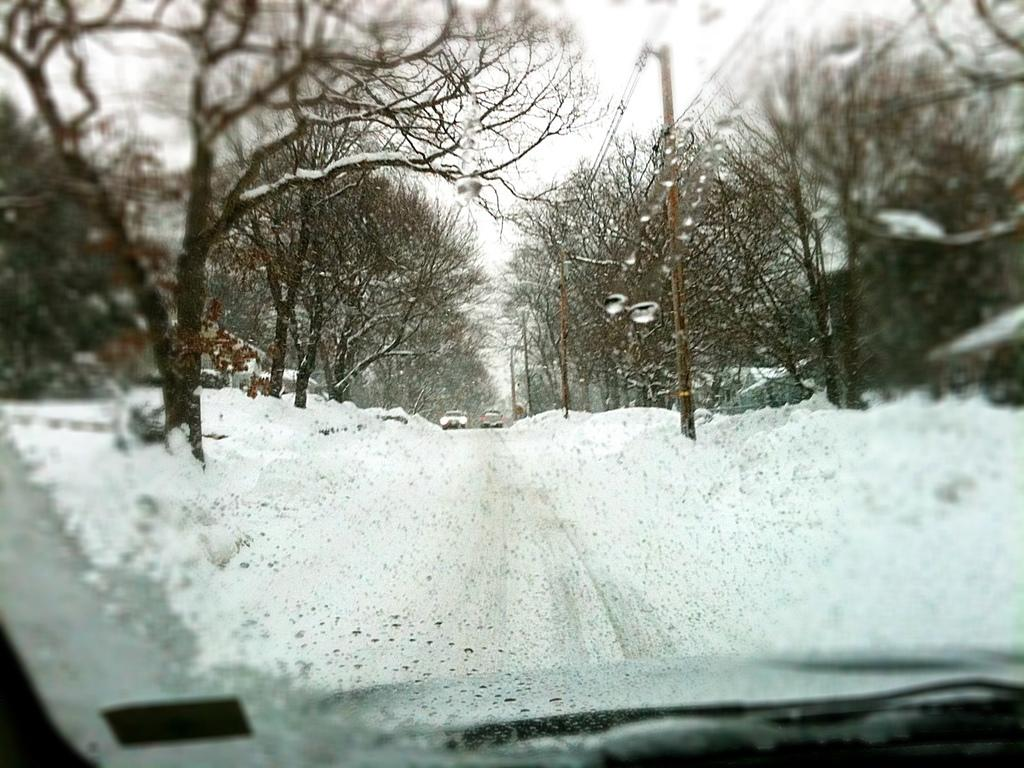What part of a vehicle is visible in the image? The front glass of a vehicle is visible in the image. What is the condition of the ground in the image? Snow is visible on the ground in the image. What type of trees can be seen in the image? There are bare trees in the image. Are there any other vehicles in the image? Yes, other vehicles are present in the image. What else can be seen in the image besides the vehicles? Poles and wires, buildings, and the sky are visible in the image. What type of beast can be seen walking on the sidewalk in the image? There is no beast or sidewalk present in the image; it shows the front glass of a vehicle with snow on the ground and other details. 